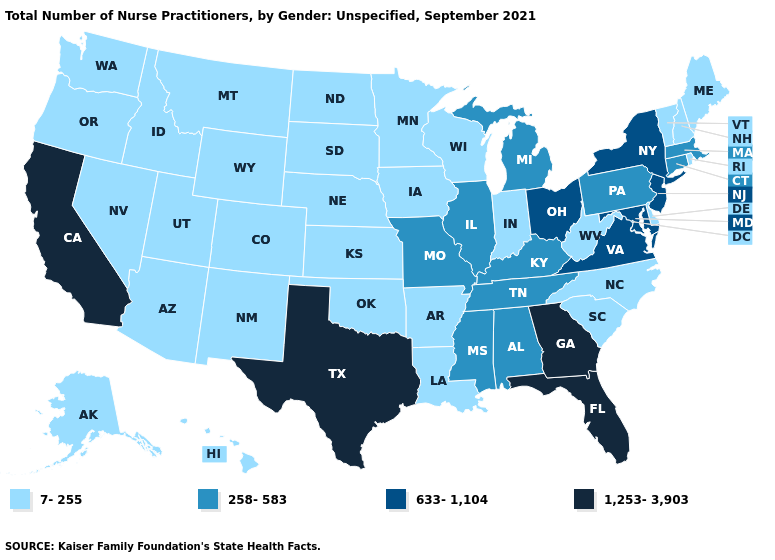Does Virginia have a lower value than New Jersey?
Quick response, please. No. What is the value of Pennsylvania?
Give a very brief answer. 258-583. Does the first symbol in the legend represent the smallest category?
Write a very short answer. Yes. Does Montana have the highest value in the West?
Give a very brief answer. No. Name the states that have a value in the range 633-1,104?
Keep it brief. Maryland, New Jersey, New York, Ohio, Virginia. What is the value of Nebraska?
Concise answer only. 7-255. Does the map have missing data?
Concise answer only. No. Among the states that border Oregon , does Washington have the lowest value?
Answer briefly. Yes. Does Alabama have the same value as North Dakota?
Write a very short answer. No. Which states have the lowest value in the USA?
Keep it brief. Alaska, Arizona, Arkansas, Colorado, Delaware, Hawaii, Idaho, Indiana, Iowa, Kansas, Louisiana, Maine, Minnesota, Montana, Nebraska, Nevada, New Hampshire, New Mexico, North Carolina, North Dakota, Oklahoma, Oregon, Rhode Island, South Carolina, South Dakota, Utah, Vermont, Washington, West Virginia, Wisconsin, Wyoming. Name the states that have a value in the range 1,253-3,903?
Be succinct. California, Florida, Georgia, Texas. Among the states that border Illinois , which have the lowest value?
Be succinct. Indiana, Iowa, Wisconsin. What is the highest value in the Northeast ?
Short answer required. 633-1,104. Name the states that have a value in the range 7-255?
Be succinct. Alaska, Arizona, Arkansas, Colorado, Delaware, Hawaii, Idaho, Indiana, Iowa, Kansas, Louisiana, Maine, Minnesota, Montana, Nebraska, Nevada, New Hampshire, New Mexico, North Carolina, North Dakota, Oklahoma, Oregon, Rhode Island, South Carolina, South Dakota, Utah, Vermont, Washington, West Virginia, Wisconsin, Wyoming. Does Wisconsin have the highest value in the USA?
Concise answer only. No. 